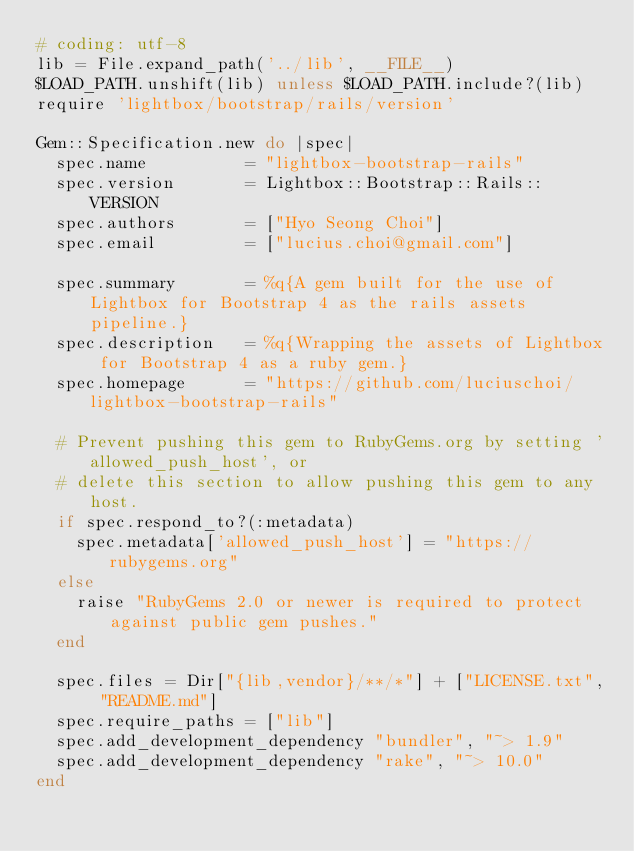Convert code to text. <code><loc_0><loc_0><loc_500><loc_500><_Ruby_># coding: utf-8
lib = File.expand_path('../lib', __FILE__)
$LOAD_PATH.unshift(lib) unless $LOAD_PATH.include?(lib)
require 'lightbox/bootstrap/rails/version'

Gem::Specification.new do |spec|
  spec.name          = "lightbox-bootstrap-rails"
  spec.version       = Lightbox::Bootstrap::Rails::VERSION
  spec.authors       = ["Hyo Seong Choi"]
  spec.email         = ["lucius.choi@gmail.com"]

  spec.summary       = %q{A gem built for the use of Lightbox for Bootstrap 4 as the rails assets pipeline.}
  spec.description   = %q{Wrapping the assets of Lightbox for Bootstrap 4 as a ruby gem.}
  spec.homepage      = "https://github.com/luciuschoi/lightbox-bootstrap-rails"

  # Prevent pushing this gem to RubyGems.org by setting 'allowed_push_host', or
  # delete this section to allow pushing this gem to any host.
  if spec.respond_to?(:metadata)
    spec.metadata['allowed_push_host'] = "https://rubygems.org"
  else
    raise "RubyGems 2.0 or newer is required to protect against public gem pushes."
  end

  spec.files = Dir["{lib,vendor}/**/*"] + ["LICENSE.txt", "README.md"]
  spec.require_paths = ["lib"]
  spec.add_development_dependency "bundler", "~> 1.9"
  spec.add_development_dependency "rake", "~> 10.0"
end
</code> 